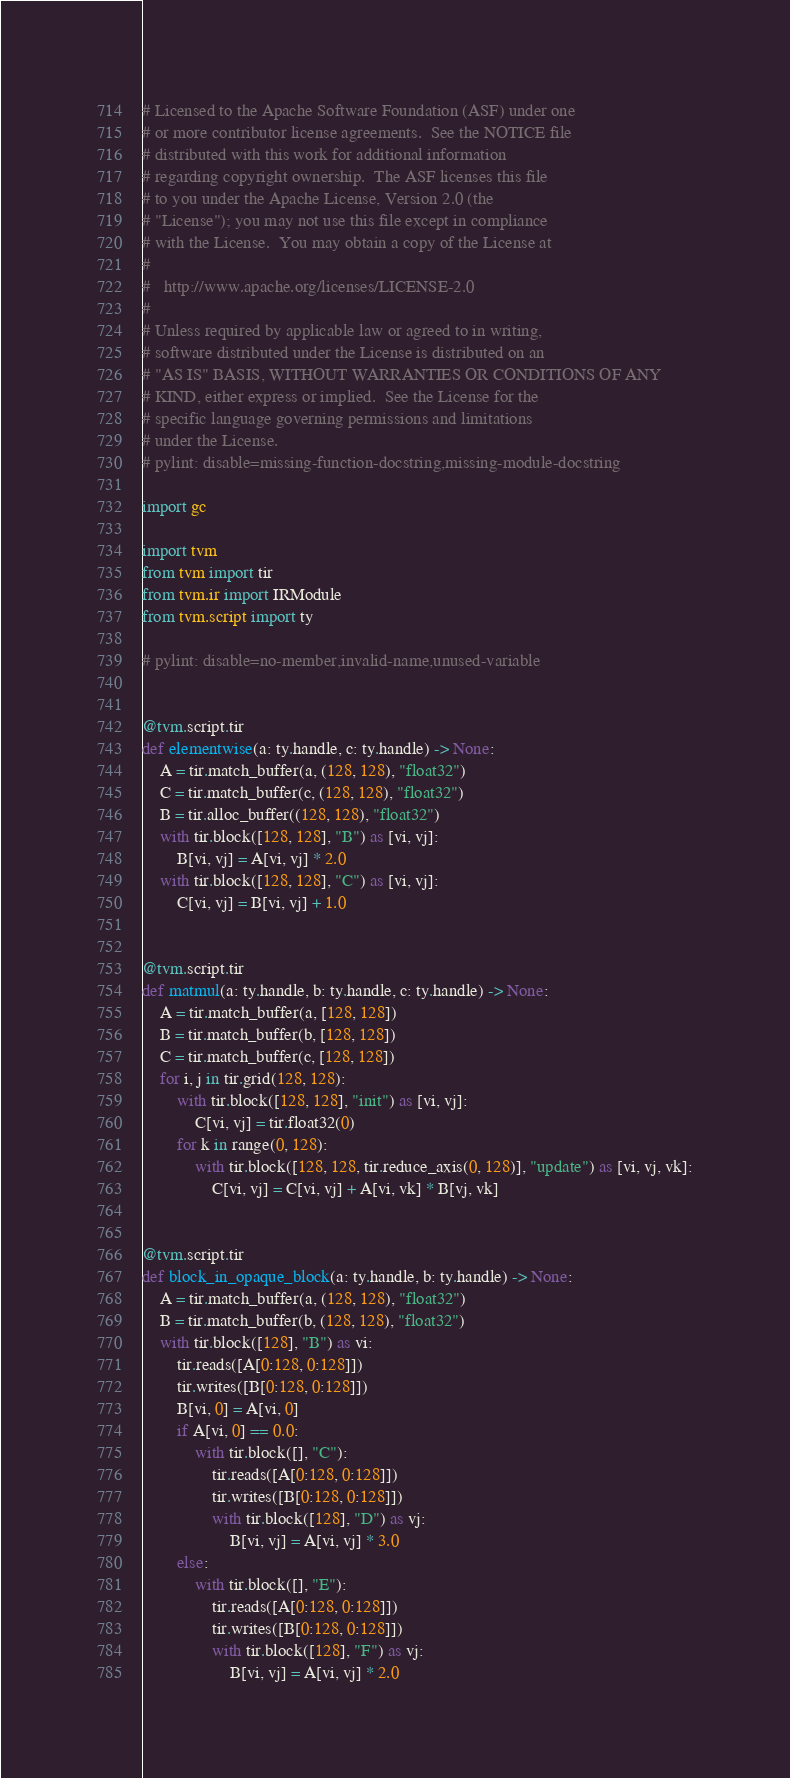<code> <loc_0><loc_0><loc_500><loc_500><_Python_># Licensed to the Apache Software Foundation (ASF) under one
# or more contributor license agreements.  See the NOTICE file
# distributed with this work for additional information
# regarding copyright ownership.  The ASF licenses this file
# to you under the Apache License, Version 2.0 (the
# "License"); you may not use this file except in compliance
# with the License.  You may obtain a copy of the License at
#
#   http://www.apache.org/licenses/LICENSE-2.0
#
# Unless required by applicable law or agreed to in writing,
# software distributed under the License is distributed on an
# "AS IS" BASIS, WITHOUT WARRANTIES OR CONDITIONS OF ANY
# KIND, either express or implied.  See the License for the
# specific language governing permissions and limitations
# under the License.
# pylint: disable=missing-function-docstring,missing-module-docstring

import gc

import tvm
from tvm import tir
from tvm.ir import IRModule
from tvm.script import ty

# pylint: disable=no-member,invalid-name,unused-variable


@tvm.script.tir
def elementwise(a: ty.handle, c: ty.handle) -> None:
    A = tir.match_buffer(a, (128, 128), "float32")
    C = tir.match_buffer(c, (128, 128), "float32")
    B = tir.alloc_buffer((128, 128), "float32")
    with tir.block([128, 128], "B") as [vi, vj]:
        B[vi, vj] = A[vi, vj] * 2.0
    with tir.block([128, 128], "C") as [vi, vj]:
        C[vi, vj] = B[vi, vj] + 1.0


@tvm.script.tir
def matmul(a: ty.handle, b: ty.handle, c: ty.handle) -> None:
    A = tir.match_buffer(a, [128, 128])
    B = tir.match_buffer(b, [128, 128])
    C = tir.match_buffer(c, [128, 128])
    for i, j in tir.grid(128, 128):
        with tir.block([128, 128], "init") as [vi, vj]:
            C[vi, vj] = tir.float32(0)
        for k in range(0, 128):
            with tir.block([128, 128, tir.reduce_axis(0, 128)], "update") as [vi, vj, vk]:
                C[vi, vj] = C[vi, vj] + A[vi, vk] * B[vj, vk]


@tvm.script.tir
def block_in_opaque_block(a: ty.handle, b: ty.handle) -> None:
    A = tir.match_buffer(a, (128, 128), "float32")
    B = tir.match_buffer(b, (128, 128), "float32")
    with tir.block([128], "B") as vi:
        tir.reads([A[0:128, 0:128]])
        tir.writes([B[0:128, 0:128]])
        B[vi, 0] = A[vi, 0]
        if A[vi, 0] == 0.0:
            with tir.block([], "C"):
                tir.reads([A[0:128, 0:128]])
                tir.writes([B[0:128, 0:128]])
                with tir.block([128], "D") as vj:
                    B[vi, vj] = A[vi, vj] * 3.0
        else:
            with tir.block([], "E"):
                tir.reads([A[0:128, 0:128]])
                tir.writes([B[0:128, 0:128]])
                with tir.block([128], "F") as vj:
                    B[vi, vj] = A[vi, vj] * 2.0

</code> 